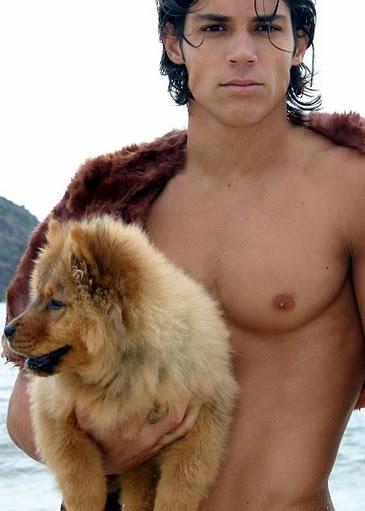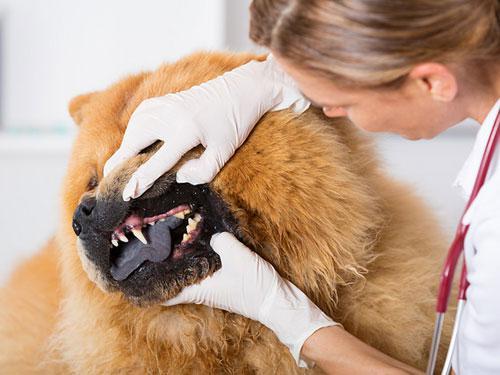The first image is the image on the left, the second image is the image on the right. Considering the images on both sides, is "The left image contains a human holding a chow dog." valid? Answer yes or no. Yes. The first image is the image on the left, the second image is the image on the right. Examine the images to the left and right. Is the description "The pair of pictures shows exactly two dogs and no human." accurate? Answer yes or no. No. The first image is the image on the left, the second image is the image on the right. Given the left and right images, does the statement "The image on the left contains a person holding onto a dog." hold true? Answer yes or no. Yes. 